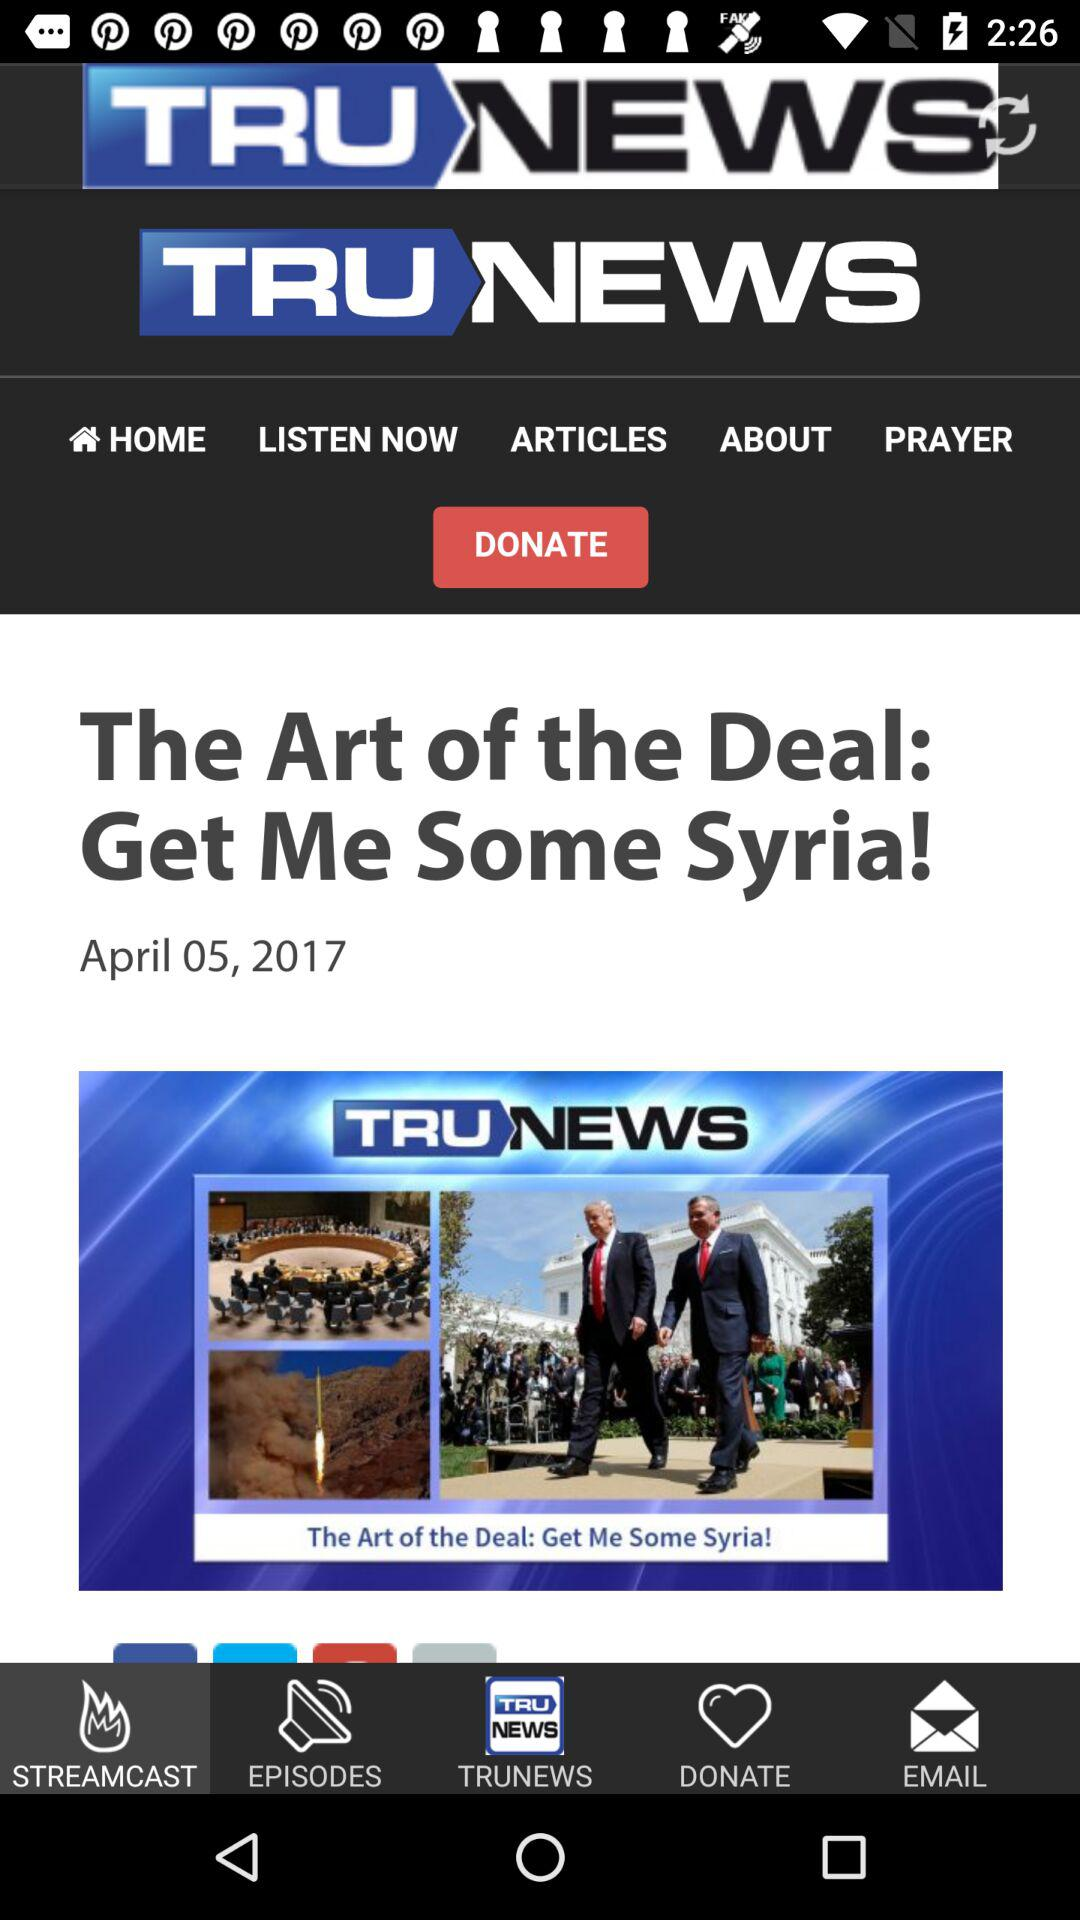When was the article published? The article was published on April 5, 2017. 